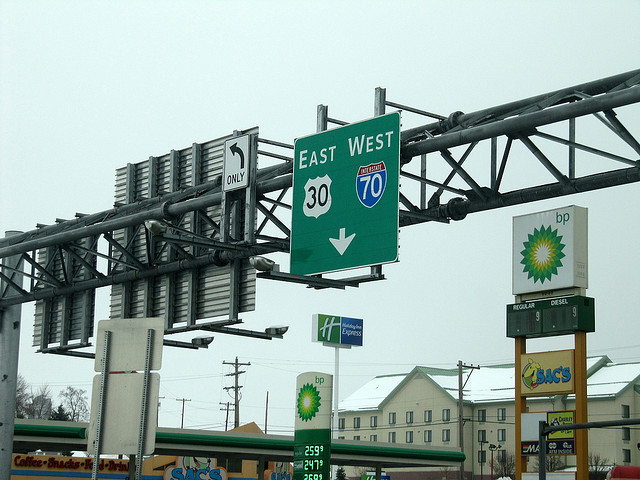Please identify all text content in this image. EAST WEST 30 70 Drinks Snacks Caffee 247' 259 Express H ATM 9 9 CISEL bp ONLY 